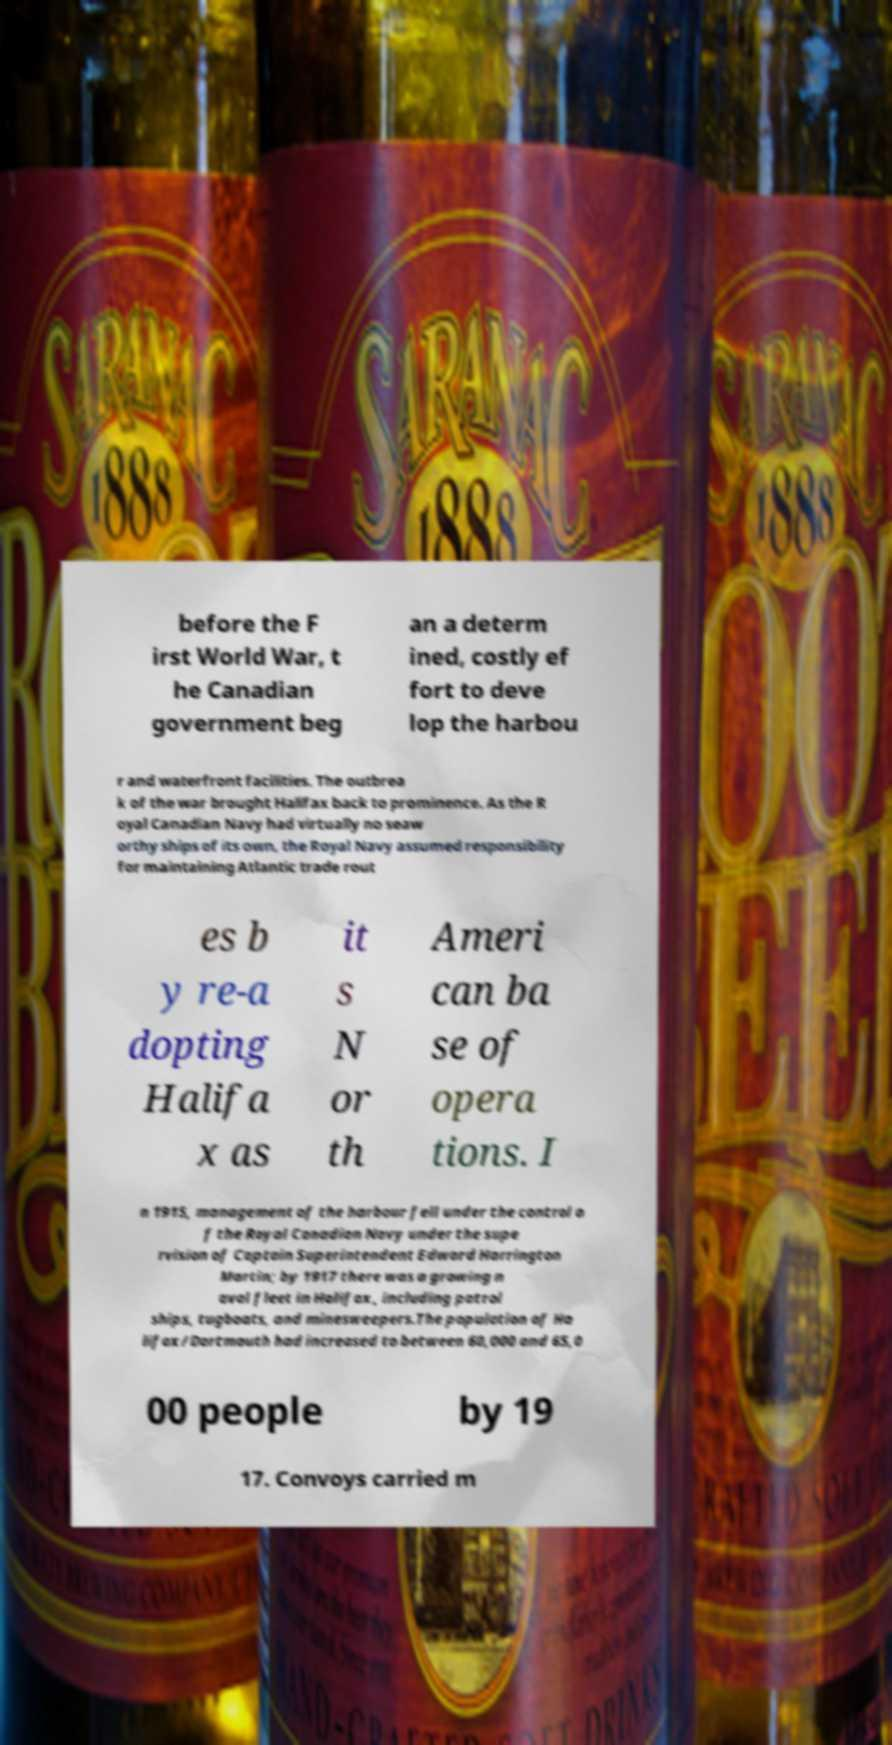For documentation purposes, I need the text within this image transcribed. Could you provide that? before the F irst World War, t he Canadian government beg an a determ ined, costly ef fort to deve lop the harbou r and waterfront facilities. The outbrea k of the war brought Halifax back to prominence. As the R oyal Canadian Navy had virtually no seaw orthy ships of its own, the Royal Navy assumed responsibility for maintaining Atlantic trade rout es b y re-a dopting Halifa x as it s N or th Ameri can ba se of opera tions. I n 1915, management of the harbour fell under the control o f the Royal Canadian Navy under the supe rvision of Captain Superintendent Edward Harrington Martin; by 1917 there was a growing n aval fleet in Halifax, including patrol ships, tugboats, and minesweepers.The population of Ha lifax/Dartmouth had increased to between 60,000 and 65,0 00 people by 19 17. Convoys carried m 